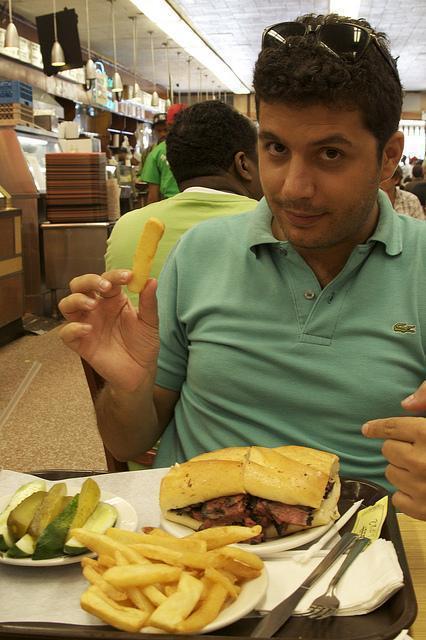The type of restaurant the man is eating at is more likely a what?
Select the accurate answer and provide justification: `Answer: choice
Rationale: srationale.`
Options: Chinese, mexican food, steakhouse, italian cuisine. Answer: steakhouse.
Rationale: The man is eating a steak sandwich. 